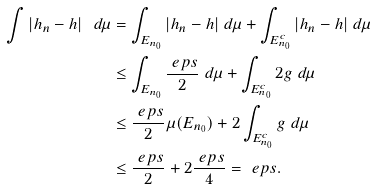Convert formula to latex. <formula><loc_0><loc_0><loc_500><loc_500>\int | h _ { n } - h | \ d \mu & = \int _ { E _ { n _ { 0 } } } | h _ { n } - h | \ d \mu + \int _ { E _ { n _ { 0 } } ^ { c } } | h _ { n } - h | \ d \mu \\ & \leq \int _ { E _ { n _ { 0 } } } \frac { \ e p s } { 2 } \ d \mu + \int _ { E _ { n _ { 0 } } ^ { c } } 2 g \ d \mu \\ & \leq \frac { \ e p s } { 2 } \mu ( E _ { n _ { 0 } } ) + 2 \int _ { E _ { n _ { 0 } } ^ { c } } g \ d \mu \\ & \leq \frac { \ e p s } { 2 } + 2 \frac { \ e p s } { 4 } = \ e p s . \\</formula> 